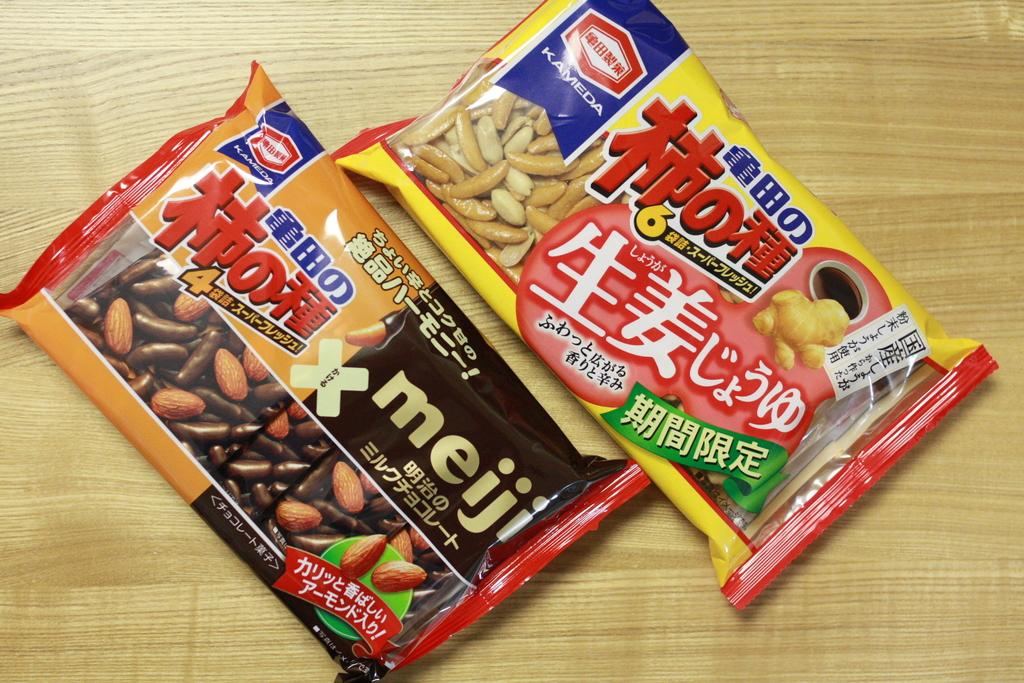What can be seen in the image related to food items? There are food item packets in the image. Where are the food item packets located? The food item packets are on a table. What brand or company is associated with the food item packets? The plastic cover of the packets has the word "Meiji" written on it. How does the table in the image move or change position? The table in the image does not move or change position; it is stationary. What type of letter is present in the image? There is no letter present in the image, only the word "Meiji" written on the plastic cover of the food item packets. 